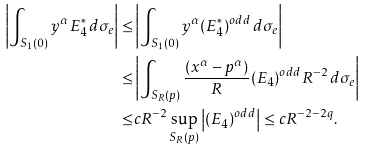Convert formula to latex. <formula><loc_0><loc_0><loc_500><loc_500>\left | \int _ { S _ { 1 } ( 0 ) } y ^ { \alpha } E _ { 4 } ^ { * } \, d \sigma _ { e } \right | \leq & \left | \int _ { S _ { 1 } ( 0 ) } y ^ { \alpha } ( E _ { 4 } ^ { * } ) ^ { o d d } \, d \sigma _ { e } \right | \\ \leq & \left | \int _ { S _ { R } ( p ) } \frac { ( x ^ { \alpha } - p ^ { \alpha } ) } { R } ( E _ { 4 } ) ^ { o d d } R ^ { - 2 } \, d \sigma _ { e } \right | \\ \leq & c R ^ { - 2 } \sup _ { S _ { R } ( p ) } \left | ( E _ { 4 } ) ^ { o d d } \right | \leq c R ^ { - 2 - 2 q } .</formula> 